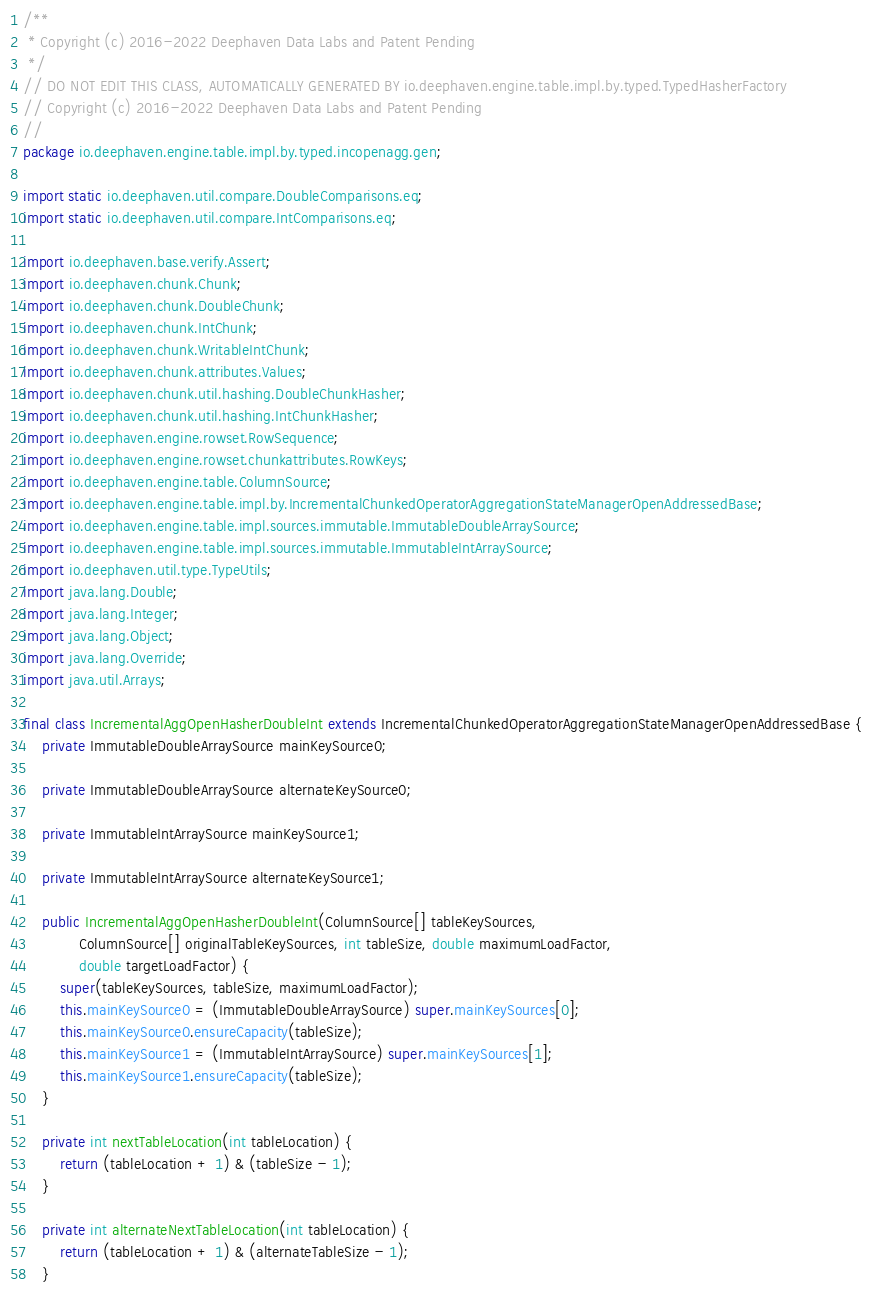<code> <loc_0><loc_0><loc_500><loc_500><_Java_>/**
 * Copyright (c) 2016-2022 Deephaven Data Labs and Patent Pending
 */
// DO NOT EDIT THIS CLASS, AUTOMATICALLY GENERATED BY io.deephaven.engine.table.impl.by.typed.TypedHasherFactory
// Copyright (c) 2016-2022 Deephaven Data Labs and Patent Pending
//
package io.deephaven.engine.table.impl.by.typed.incopenagg.gen;

import static io.deephaven.util.compare.DoubleComparisons.eq;
import static io.deephaven.util.compare.IntComparisons.eq;

import io.deephaven.base.verify.Assert;
import io.deephaven.chunk.Chunk;
import io.deephaven.chunk.DoubleChunk;
import io.deephaven.chunk.IntChunk;
import io.deephaven.chunk.WritableIntChunk;
import io.deephaven.chunk.attributes.Values;
import io.deephaven.chunk.util.hashing.DoubleChunkHasher;
import io.deephaven.chunk.util.hashing.IntChunkHasher;
import io.deephaven.engine.rowset.RowSequence;
import io.deephaven.engine.rowset.chunkattributes.RowKeys;
import io.deephaven.engine.table.ColumnSource;
import io.deephaven.engine.table.impl.by.IncrementalChunkedOperatorAggregationStateManagerOpenAddressedBase;
import io.deephaven.engine.table.impl.sources.immutable.ImmutableDoubleArraySource;
import io.deephaven.engine.table.impl.sources.immutable.ImmutableIntArraySource;
import io.deephaven.util.type.TypeUtils;
import java.lang.Double;
import java.lang.Integer;
import java.lang.Object;
import java.lang.Override;
import java.util.Arrays;

final class IncrementalAggOpenHasherDoubleInt extends IncrementalChunkedOperatorAggregationStateManagerOpenAddressedBase {
    private ImmutableDoubleArraySource mainKeySource0;

    private ImmutableDoubleArraySource alternateKeySource0;

    private ImmutableIntArraySource mainKeySource1;

    private ImmutableIntArraySource alternateKeySource1;

    public IncrementalAggOpenHasherDoubleInt(ColumnSource[] tableKeySources,
            ColumnSource[] originalTableKeySources, int tableSize, double maximumLoadFactor,
            double targetLoadFactor) {
        super(tableKeySources, tableSize, maximumLoadFactor);
        this.mainKeySource0 = (ImmutableDoubleArraySource) super.mainKeySources[0];
        this.mainKeySource0.ensureCapacity(tableSize);
        this.mainKeySource1 = (ImmutableIntArraySource) super.mainKeySources[1];
        this.mainKeySource1.ensureCapacity(tableSize);
    }

    private int nextTableLocation(int tableLocation) {
        return (tableLocation + 1) & (tableSize - 1);
    }

    private int alternateNextTableLocation(int tableLocation) {
        return (tableLocation + 1) & (alternateTableSize - 1);
    }
</code> 